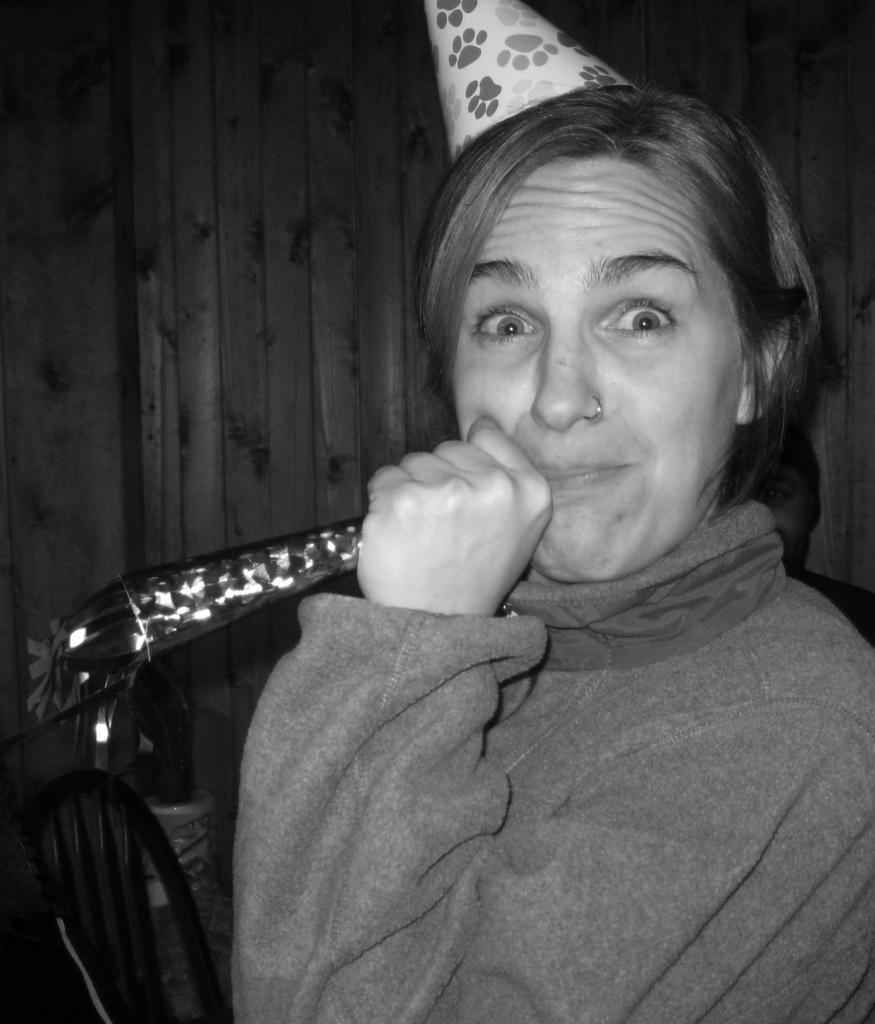Could you give a brief overview of what you see in this image? In this picture I can see a woman, she is wearing the sweater and a cap, on the left side, there is a chair, this image is in black and white color. 